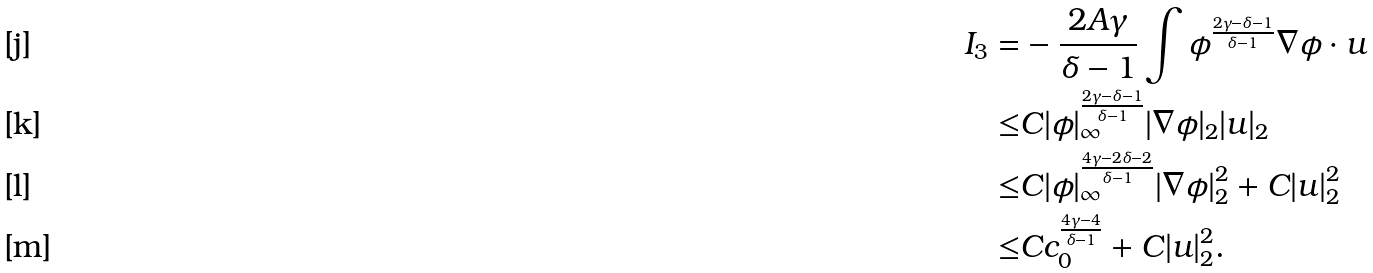<formula> <loc_0><loc_0><loc_500><loc_500>I _ { 3 } = & - \frac { 2 A \gamma } { \delta - 1 } \int \phi ^ { \frac { 2 \gamma - \delta - 1 } { \delta - 1 } } \nabla \phi \cdot u \\ \leq & C | \phi | ^ { \frac { 2 \gamma - \delta - 1 } { \delta - 1 } } _ { \infty } | \nabla \phi | _ { 2 } | u | _ { 2 } \\ \leq & C | \phi | ^ { \frac { 4 \gamma - 2 \delta - 2 } { \delta - 1 } } _ { \infty } | \nabla \phi | ^ { 2 } _ { 2 } + C | u | ^ { 2 } _ { 2 } \\ \leq & C c ^ { \frac { 4 \gamma - 4 } { \delta - 1 } } _ { 0 } + C | u | ^ { 2 } _ { 2 } .</formula> 